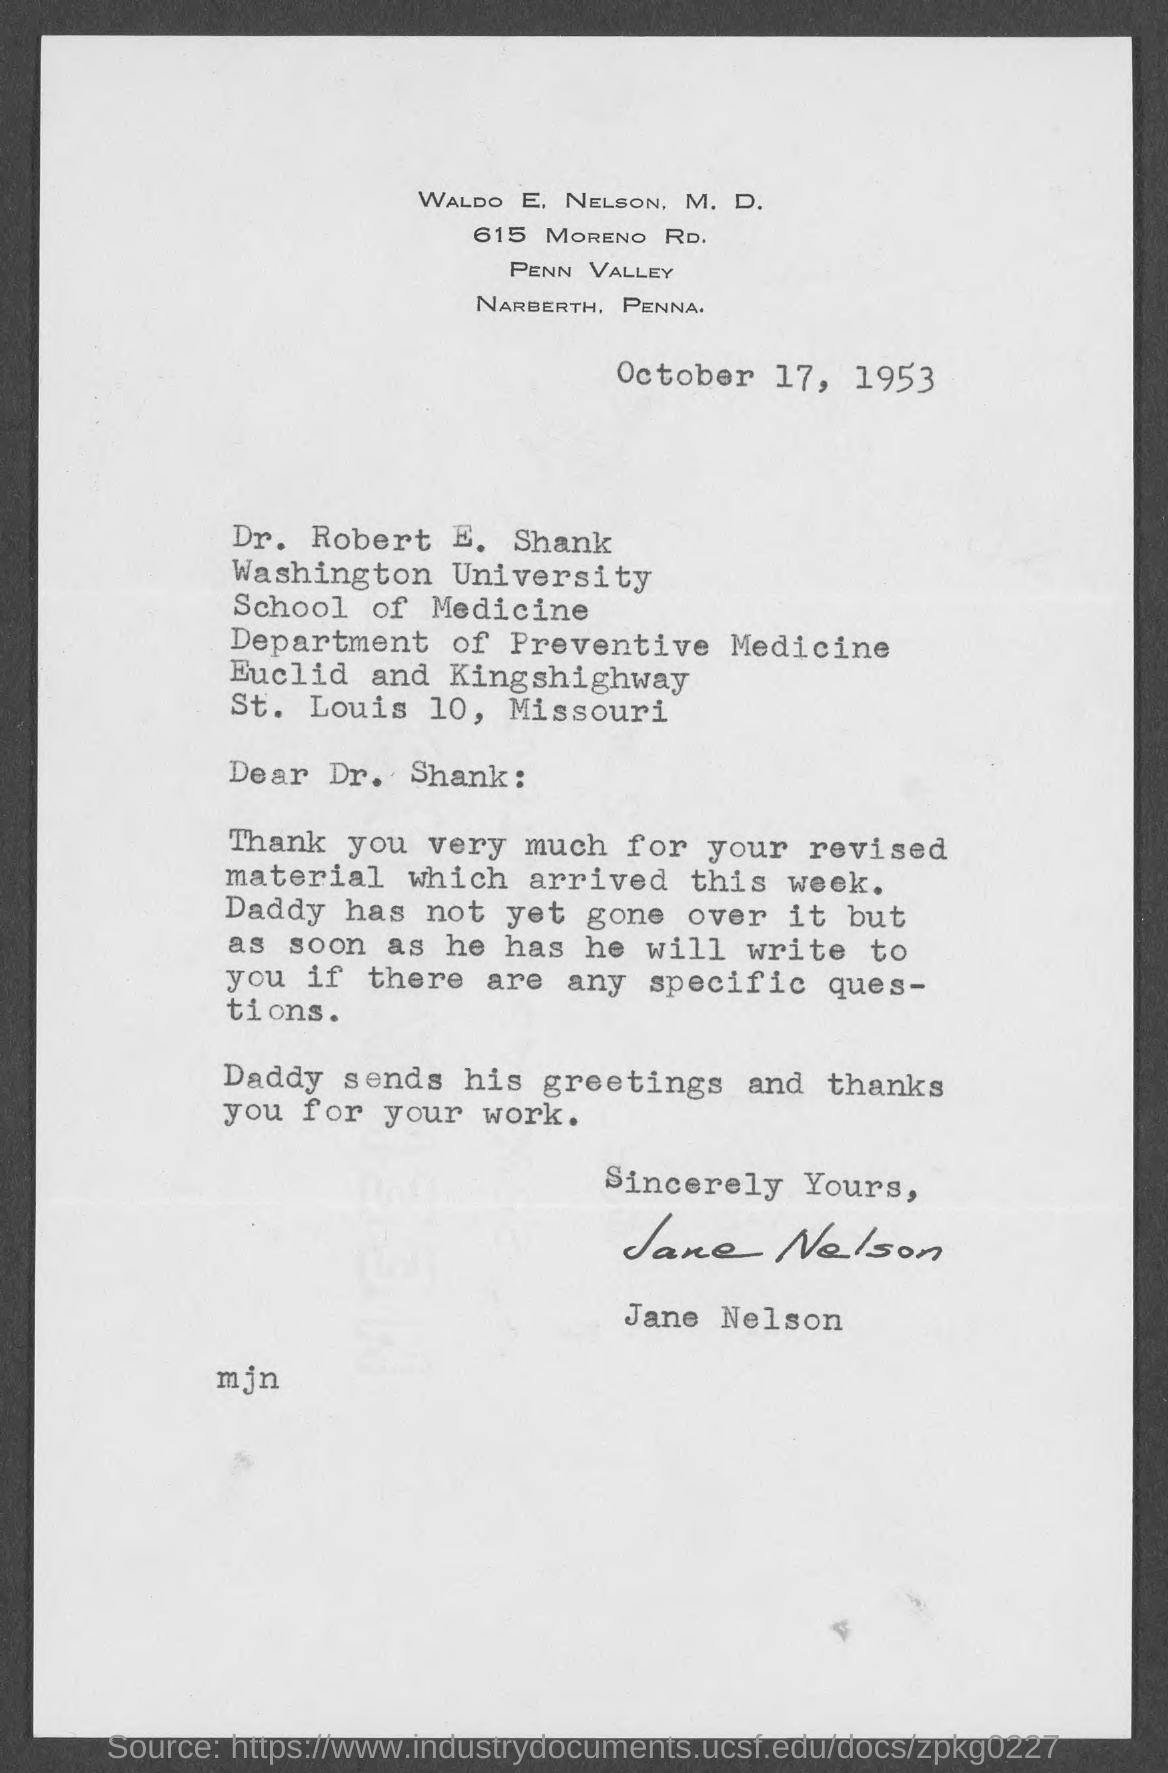Highlight a few significant elements in this photo. The date on the letter is October 17, 1953. The revised material arrived this week. The letter is addressed to Dr. Robert E. Shank. The letter is from Jane Nelson. 